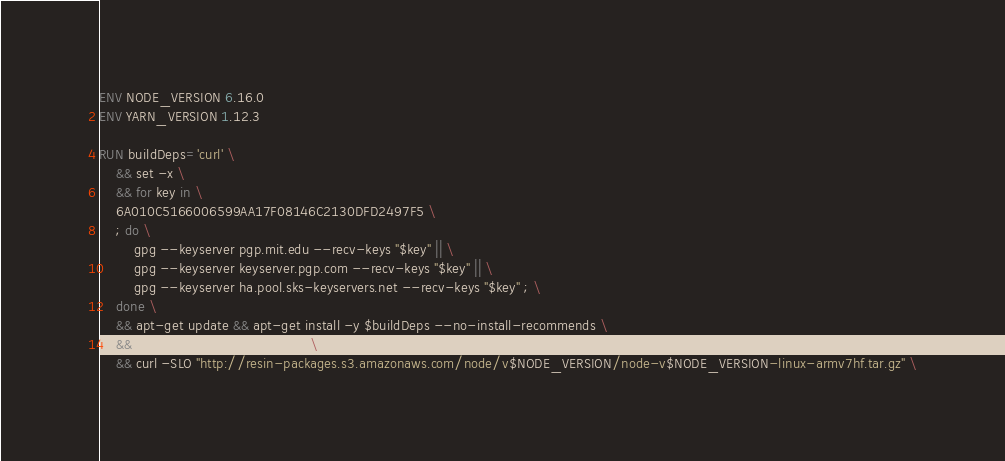<code> <loc_0><loc_0><loc_500><loc_500><_Dockerfile_>ENV NODE_VERSION 6.16.0
ENV YARN_VERSION 1.12.3

RUN buildDeps='curl' \
	&& set -x \
	&& for key in \
	6A010C5166006599AA17F08146C2130DFD2497F5 \
	; do \
		gpg --keyserver pgp.mit.edu --recv-keys "$key" || \
		gpg --keyserver keyserver.pgp.com --recv-keys "$key" || \
		gpg --keyserver ha.pool.sks-keyservers.net --recv-keys "$key" ; \
	done \
	&& apt-get update && apt-get install -y $buildDeps --no-install-recommends \
	&& rm -rf /var/lib/apt/lists/* \
	&& curl -SLO "http://resin-packages.s3.amazonaws.com/node/v$NODE_VERSION/node-v$NODE_VERSION-linux-armv7hf.tar.gz" \</code> 